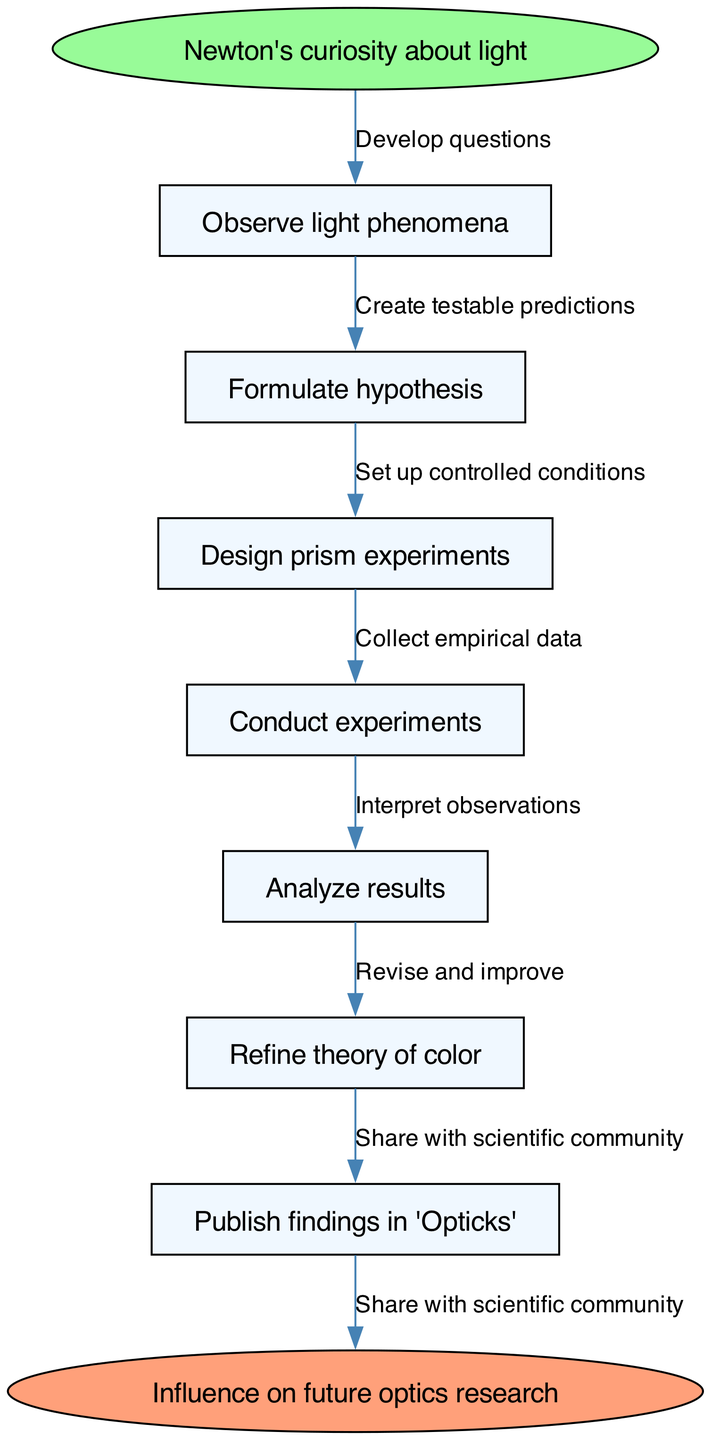What is the starting point of the diagram? The starting point, indicated by the "start" node, is "Newton's curiosity about light". This is the initial aspect of the process that prompts Newton's research into optics.
Answer: Newton's curiosity about light How many nodes are there in the diagram? The diagram includes one start node, six process nodes, and one end node, totaling eight nodes.
Answer: 8 What follows after "Formulate hypothesis"? According to the flow of the diagram, after "Formulate hypothesis" the next step is "Design prism experiments". This indicates the progression of Newton’s method following his hypothesis.
Answer: Design prism experiments What is the last node in the diagram? The last node is an end node labeled "Influence on future optics research". This concludes the flow chart representing the outcome of Newton's systematic approach.
Answer: Influence on future optics research Which step involves interpreting data? The step where data interpretation occurs is "Analyze results". This step is crucial for understanding the outcomes of the conducted experiments.
Answer: Analyze results What is the relationship between "Conduct experiments" and "Refine theory of color"? The relationship is sequential; "Conduct experiments" precedes "Refine theory of color". This shows that experimentation leads to improvements in Newton's theory.
Answer: Sequential After "Analyze results", what is the next step? The next step after "Analyze results" is "Refine theory of color". This illustrates how careful analysis leads to the enhancement of existing theories based on empirical findings.
Answer: Refine theory of color How does Newton share his findings? Newton shares his findings by publishing them in "Opticks", which indicates his contribution to the scientific community through formal documentation.
Answer: Publish findings in 'Opticks' What is the process before "Collect empirical data"? Prior to "Collect empirical data", the step is "Set up controlled conditions". This emphasizes the importance of having controlled parameters for accurate data collection.
Answer: Set up controlled conditions 